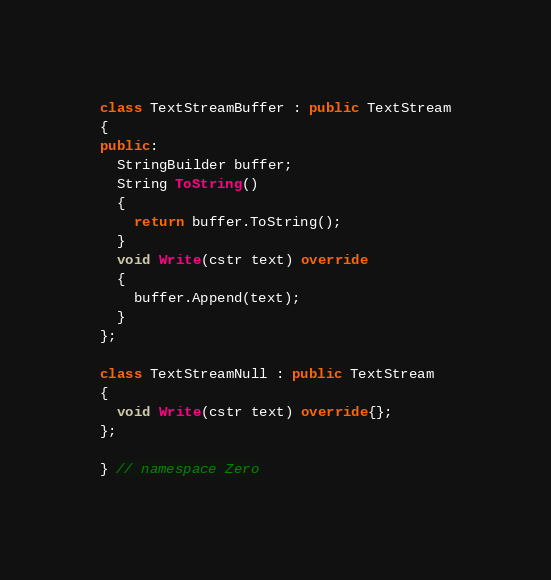Convert code to text. <code><loc_0><loc_0><loc_500><loc_500><_C++_>
class TextStreamBuffer : public TextStream
{
public:
  StringBuilder buffer;
  String ToString()
  {
    return buffer.ToString();
  }
  void Write(cstr text) override
  {
    buffer.Append(text);
  }
};

class TextStreamNull : public TextStream
{
  void Write(cstr text) override{};
};

} // namespace Zero
</code> 